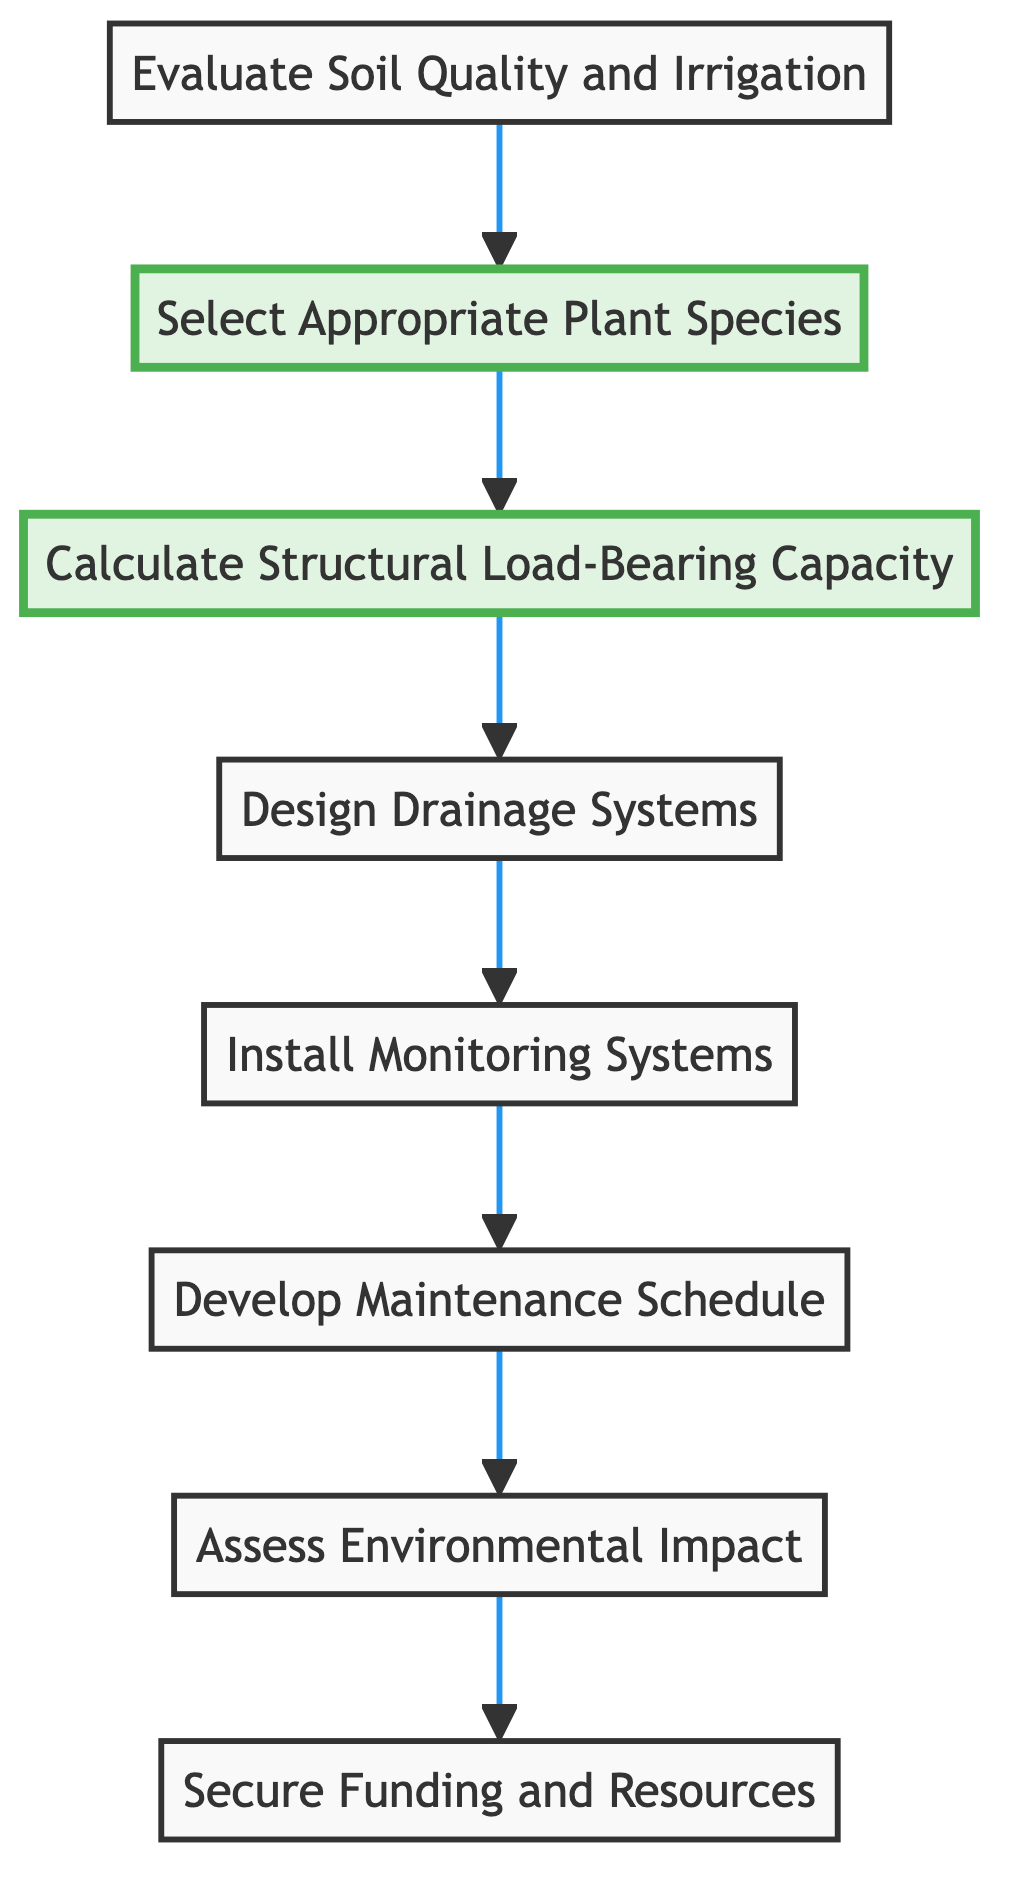What is the top node in the flowchart? The top node in the flowchart represents the final outcome of the processes described, which is "Secure Funding and Resources."
Answer: Secure Funding and Resources How many nodes are there in the diagram? The diagram contains a total of eight nodes. Each node represents a step in the assessment process for building-integrated vegetation.
Answer: Eight What is the relationship between "Develop Maintenance Schedule" and "Install Monitoring Systems"? "Develop Maintenance Schedule" follows "Install Monitoring Systems" in the flowchart, indicating that monitoring is a prerequisite step to developing a maintenance plan.
Answer: Developing Maintenance Schedule follows Installing Monitoring Systems Which two nodes are highlighted in the diagram? The highlighted nodes are "Calculate Structural Load-Bearing Capacity" and "Select Appropriate Plant Species," indicating their significance in the assessment process.
Answer: Calculate Structural Load-Bearing Capacity, Select Appropriate Plant Species What is the flow direction of the diagram? The flow direction of the diagram is from the bottom to the top, showcasing a sequential process where each step builds upon the previous one.
Answer: Bottom to Top How does "Assess Environmental Impact" relate to "Develop Maintenance Schedule"? "Assess Environmental Impact" is the last node before "Secure Funding and Resources," suggesting that understanding environmental impacts is important before establishing a maintenance schedule that secures ongoing resources.
Answer: Assess Environmental Impact leads to Secure Funding and Resources What is the first step in the process according to the flowchart? The first step in the flowchart is "Evaluate Soil Quality and Irrigation," indicating the initial assessment that needs to take place.
Answer: Evaluate Soil Quality and Irrigation What does the flowchart describe? The flowchart illustrates the steps necessary for "Assessing Long-Term Maintenance and Sustainability of Building-Integrated Vegetation," providing a structured approach to this integration task.
Answer: Assessing Long-Term Maintenance and Sustainability of Building-Integrated Vegetation 